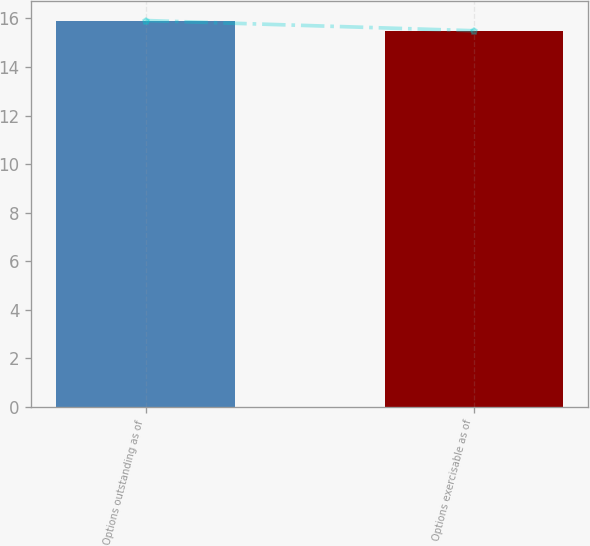Convert chart to OTSL. <chart><loc_0><loc_0><loc_500><loc_500><bar_chart><fcel>Options outstanding as of<fcel>Options exercisable as of<nl><fcel>15.91<fcel>15.49<nl></chart> 